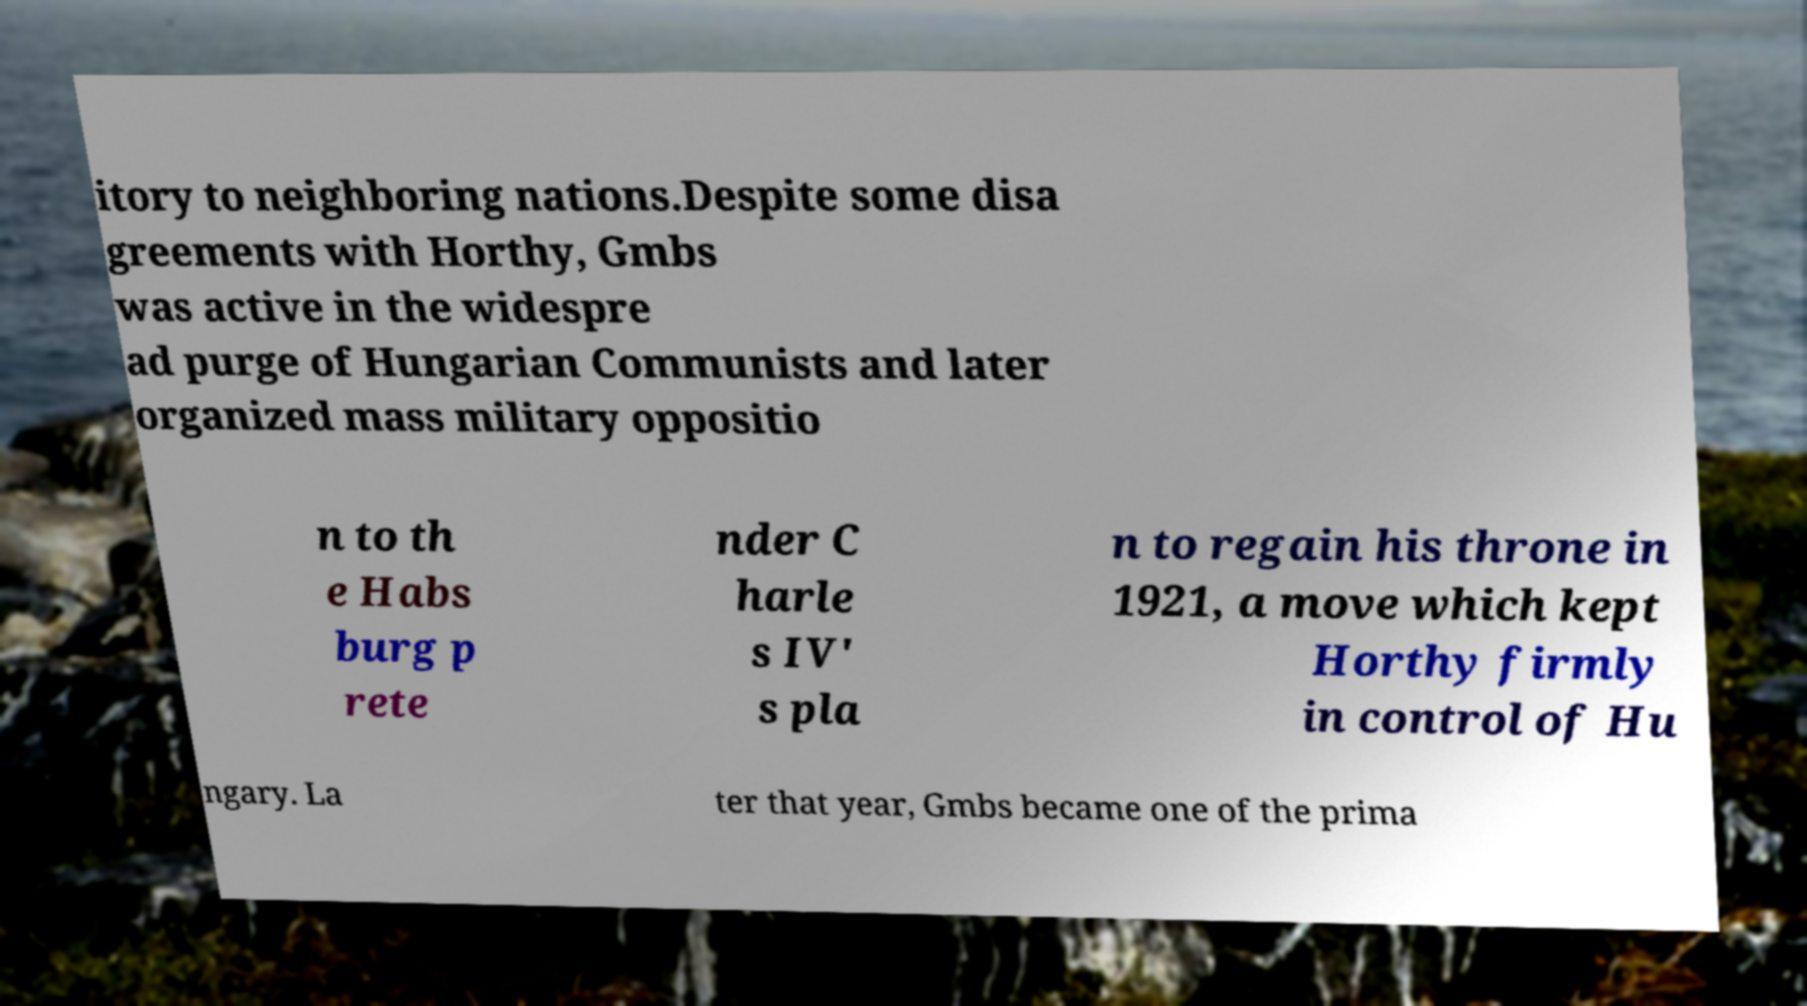For documentation purposes, I need the text within this image transcribed. Could you provide that? itory to neighboring nations.Despite some disa greements with Horthy, Gmbs was active in the widespre ad purge of Hungarian Communists and later organized mass military oppositio n to th e Habs burg p rete nder C harle s IV' s pla n to regain his throne in 1921, a move which kept Horthy firmly in control of Hu ngary. La ter that year, Gmbs became one of the prima 